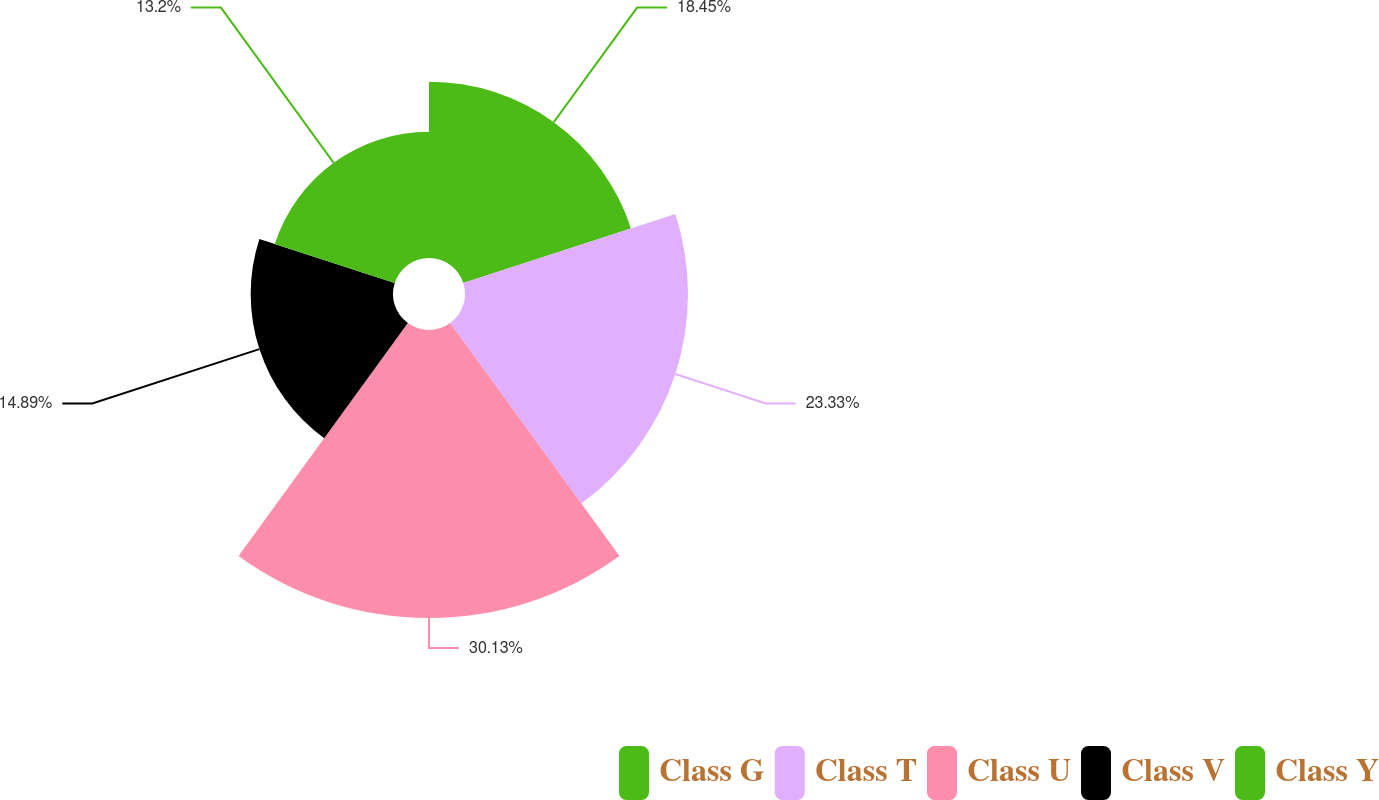<chart> <loc_0><loc_0><loc_500><loc_500><pie_chart><fcel>Class G<fcel>Class T<fcel>Class U<fcel>Class V<fcel>Class Y<nl><fcel>18.45%<fcel>23.33%<fcel>30.13%<fcel>14.89%<fcel>13.2%<nl></chart> 